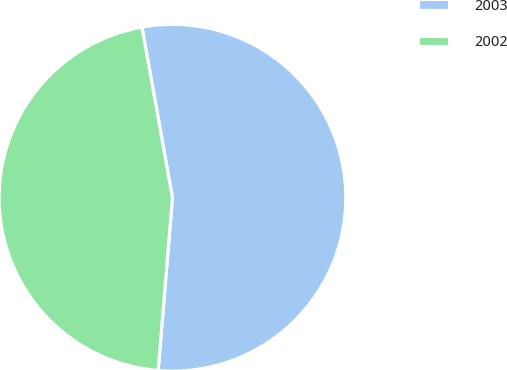Convert chart to OTSL. <chart><loc_0><loc_0><loc_500><loc_500><pie_chart><fcel>2003<fcel>2002<nl><fcel>54.13%<fcel>45.87%<nl></chart> 